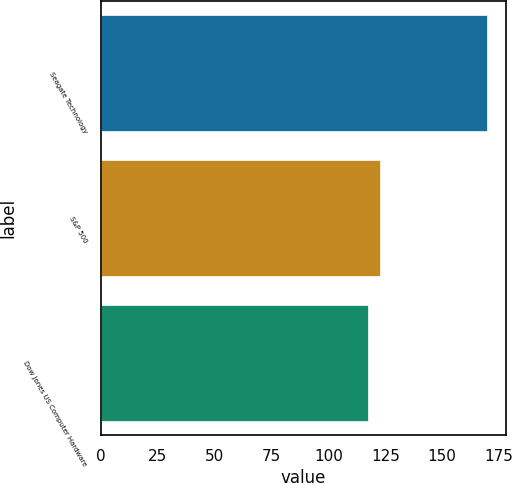Convert chart to OTSL. <chart><loc_0><loc_0><loc_500><loc_500><bar_chart><fcel>Seagate Technology<fcel>S&P 500<fcel>Dow Jones US Computer Hardware<nl><fcel>169.53<fcel>122.7<fcel>117.5<nl></chart> 